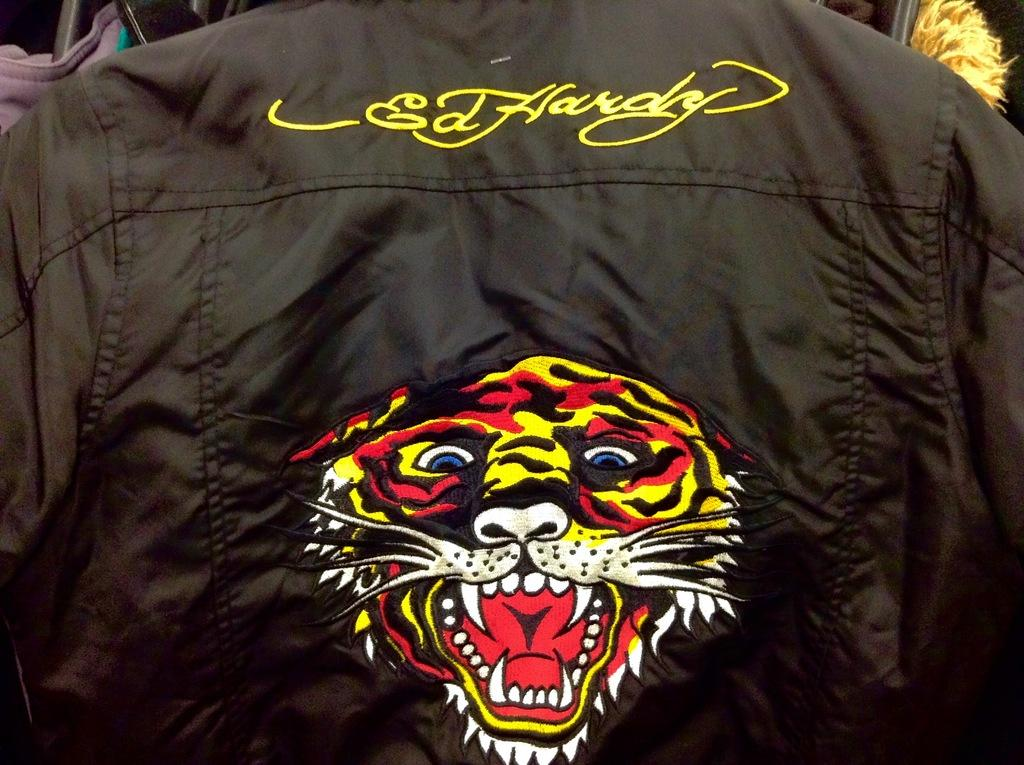What is featured on the shirt in the image? There is an embroidery on a shirt in the image. What type of ornament is hanging from the tree in the image? There is no tree or ornament present in the image; it only features a shirt with embroidery. What type of berry can be seen growing on the shirt in the image? There are no berries present on the shirt in the image; it only features an embroidery. 